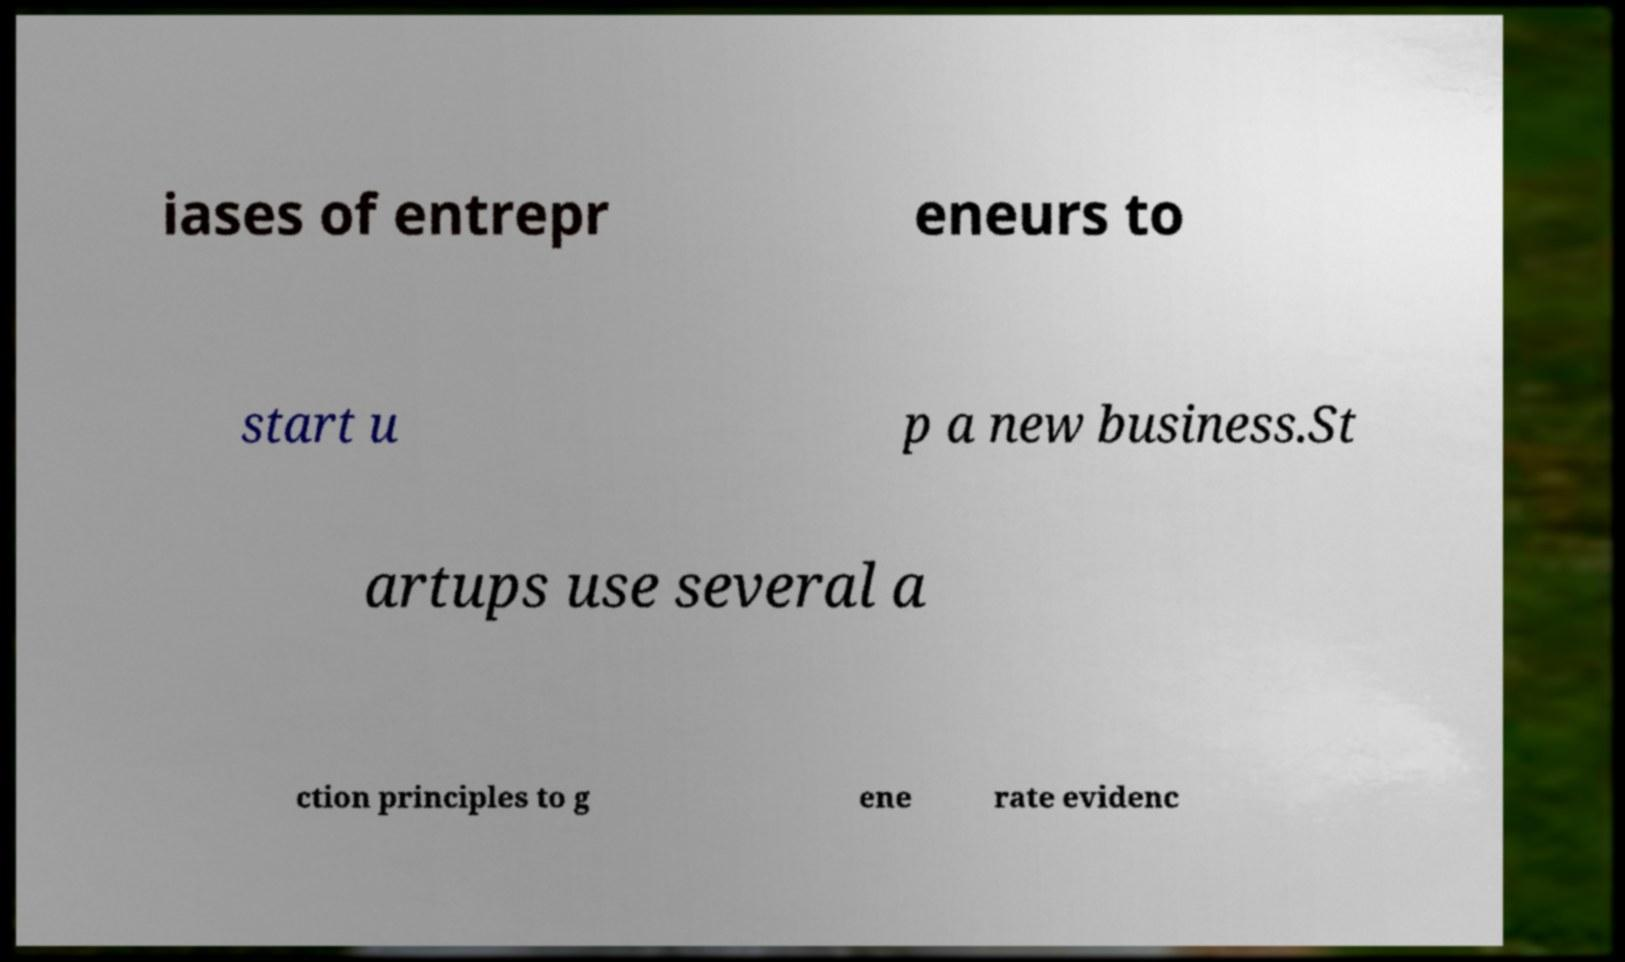I need the written content from this picture converted into text. Can you do that? iases of entrepr eneurs to start u p a new business.St artups use several a ction principles to g ene rate evidenc 